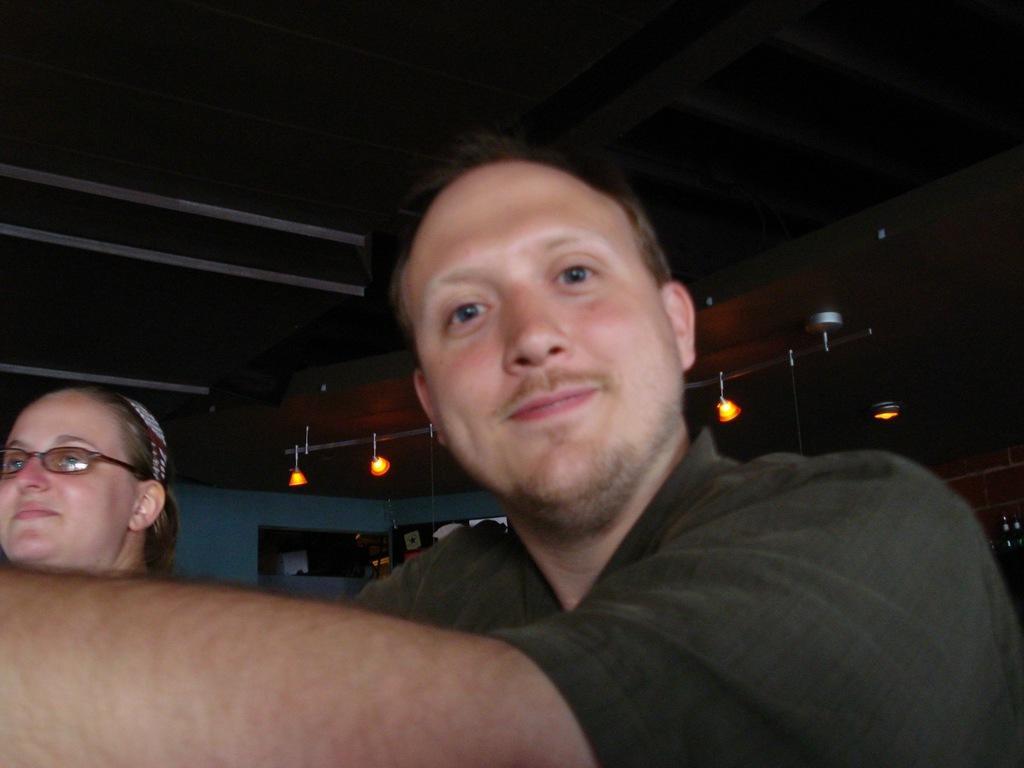Could you give a brief overview of what you see in this image? In this image we can see two people. At the top of the image there is ceiling. There are lights. In the background of the image there is wall. 